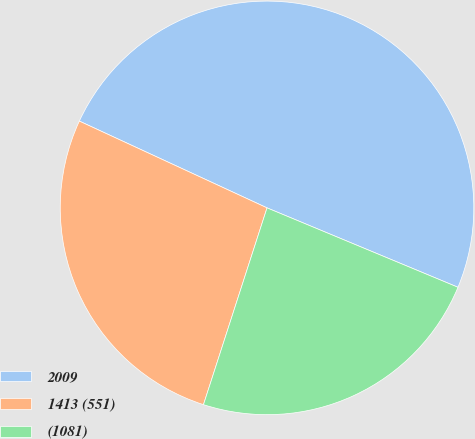Convert chart to OTSL. <chart><loc_0><loc_0><loc_500><loc_500><pie_chart><fcel>2009<fcel>1413 (551)<fcel>(1081)<nl><fcel>49.38%<fcel>26.92%<fcel>23.7%<nl></chart> 